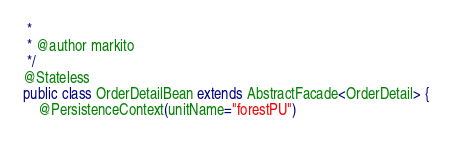Convert code to text. <code><loc_0><loc_0><loc_500><loc_500><_Java_> *
 * @author markito
 */
@Stateless
public class OrderDetailBean extends AbstractFacade<OrderDetail> {
    @PersistenceContext(unitName="forestPU")</code> 